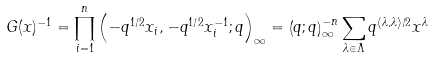<formula> <loc_0><loc_0><loc_500><loc_500>G ( x ) ^ { - 1 } = \prod _ { i = 1 } ^ { n } \left ( - q ^ { 1 / 2 } x _ { i } , - q ^ { 1 / 2 } x _ { i } ^ { - 1 } ; q \right ) _ { \infty } = \left ( q ; q \right ) _ { \infty } ^ { - n } \sum _ { \lambda \in \Lambda } q ^ { \langle \lambda , \lambda \rangle / 2 } x ^ { \lambda }</formula> 